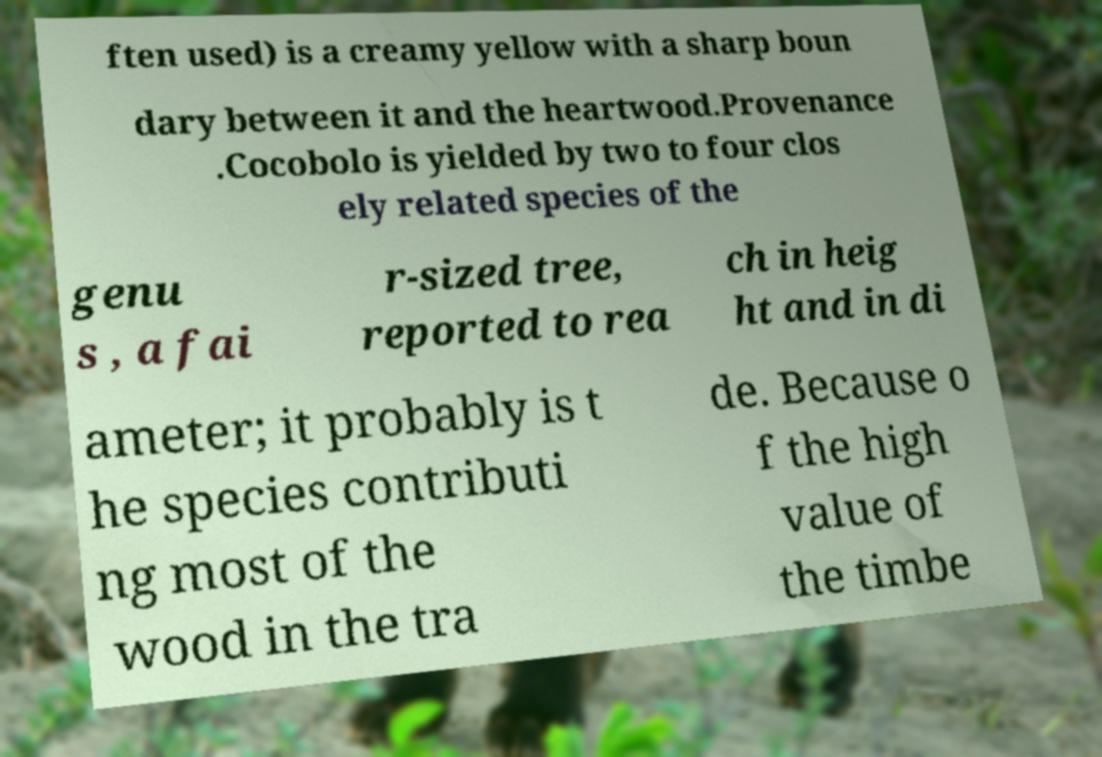Please read and relay the text visible in this image. What does it say? ften used) is a creamy yellow with a sharp boun dary between it and the heartwood.Provenance .Cocobolo is yielded by two to four clos ely related species of the genu s , a fai r-sized tree, reported to rea ch in heig ht and in di ameter; it probably is t he species contributi ng most of the wood in the tra de. Because o f the high value of the timbe 